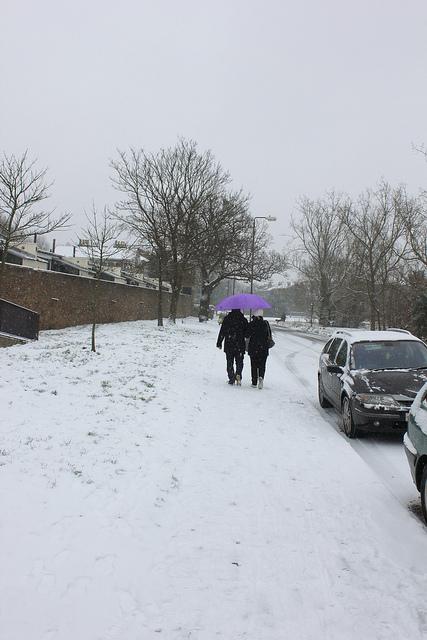What is the color of the umbrella?
Concise answer only. Purple. How many people are walking?
Short answer required. 2. Is it snowing?
Answer briefly. Yes. How many people are riding bikes here?
Give a very brief answer. 0. 